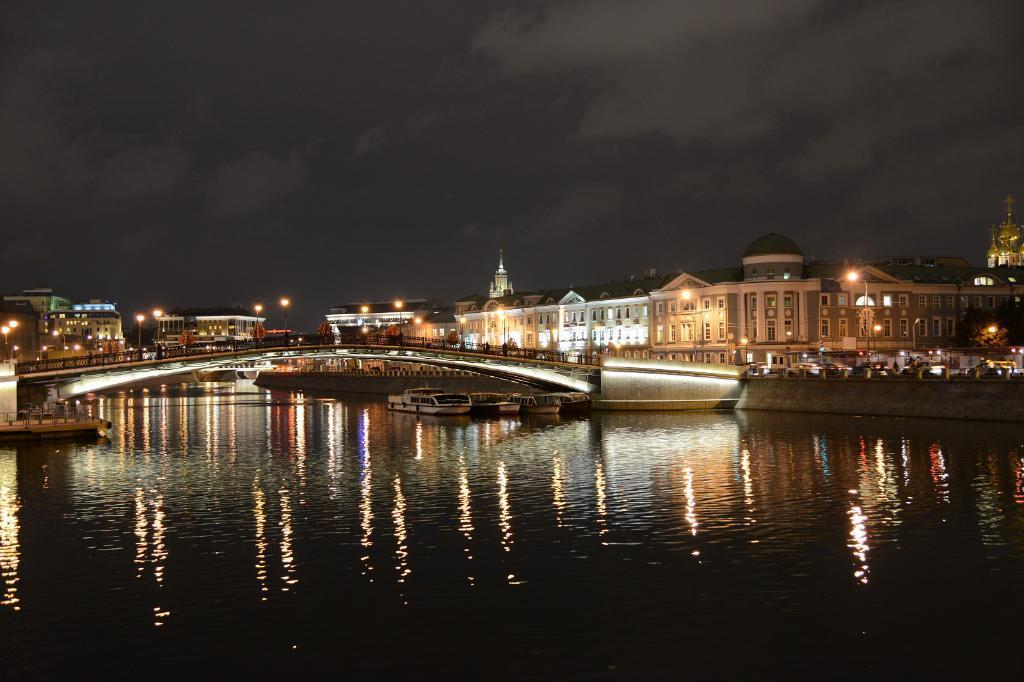Can you describe this image briefly? In this image we can see buildings, electric lights, street poles, boats, bridge, river and sky with clouds. 